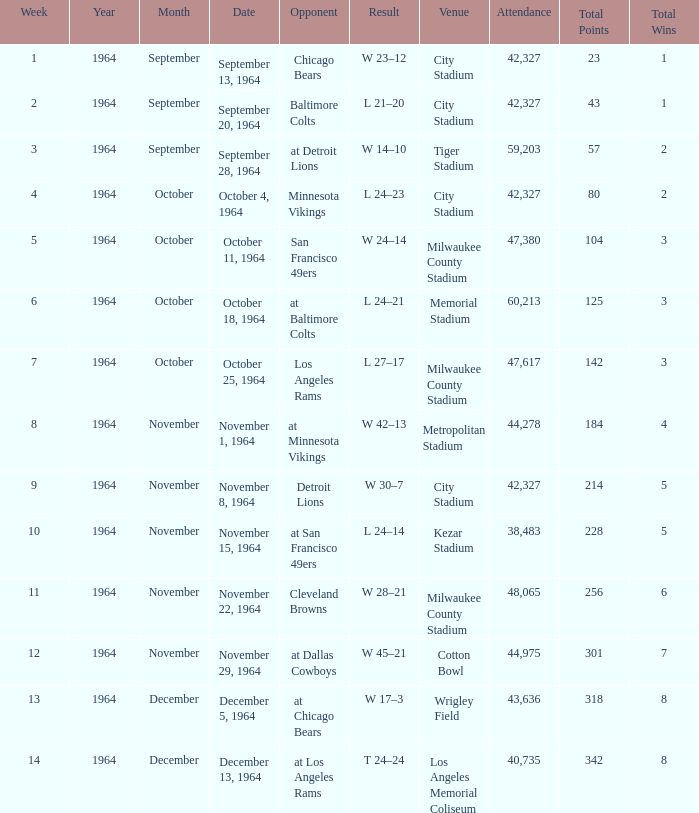What is the average week of the game on November 22, 1964 attended by 48,065? None. Can you give me this table as a dict? {'header': ['Week', 'Year', 'Month', 'Date', 'Opponent', 'Result', 'Venue', 'Attendance', 'Total Points', 'Total Wins'], 'rows': [['1', '1964', 'September', 'September 13, 1964', 'Chicago Bears', 'W 23–12', 'City Stadium', '42,327', '23', '1'], ['2', '1964', 'September', 'September 20, 1964', 'Baltimore Colts', 'L 21–20', 'City Stadium', '42,327', '43', '1'], ['3', '1964', 'September', 'September 28, 1964', 'at Detroit Lions', 'W 14–10', 'Tiger Stadium', '59,203', '57', '2'], ['4', '1964', 'October', 'October 4, 1964', 'Minnesota Vikings', 'L 24–23', 'City Stadium', '42,327', '80', '2'], ['5', '1964', 'October', 'October 11, 1964', 'San Francisco 49ers', 'W 24–14', 'Milwaukee County Stadium', '47,380', '104', '3'], ['6', '1964', 'October', 'October 18, 1964', 'at Baltimore Colts', 'L 24–21', 'Memorial Stadium', '60,213', '125', '3'], ['7', '1964', 'October', 'October 25, 1964', 'Los Angeles Rams', 'L 27–17', 'Milwaukee County Stadium', '47,617', '142', '3'], ['8', '1964', 'November', 'November 1, 1964', 'at Minnesota Vikings', 'W 42–13', 'Metropolitan Stadium', '44,278', '184', '4'], ['9', '1964', 'November', 'November 8, 1964', 'Detroit Lions', 'W 30–7', 'City Stadium', '42,327', '214', '5'], ['10', '1964', 'November', 'November 15, 1964', 'at San Francisco 49ers', 'L 24–14', 'Kezar Stadium', '38,483', '228', '5'], ['11', '1964', 'November', 'November 22, 1964', 'Cleveland Browns', 'W 28–21', 'Milwaukee County Stadium', '48,065', '256', '6'], ['12', '1964', 'November', 'November 29, 1964', 'at Dallas Cowboys', 'W 45–21', 'Cotton Bowl', '44,975', '301', '7'], ['13', '1964', 'December', 'December 5, 1964', 'at Chicago Bears', 'W 17–3', 'Wrigley Field', '43,636', '318', '8'], ['14', '1964', 'December', 'December 13, 1964', 'at Los Angeles Rams', 'T 24–24', 'Los Angeles Memorial Coliseum', '40,735', '342', '8']]} 